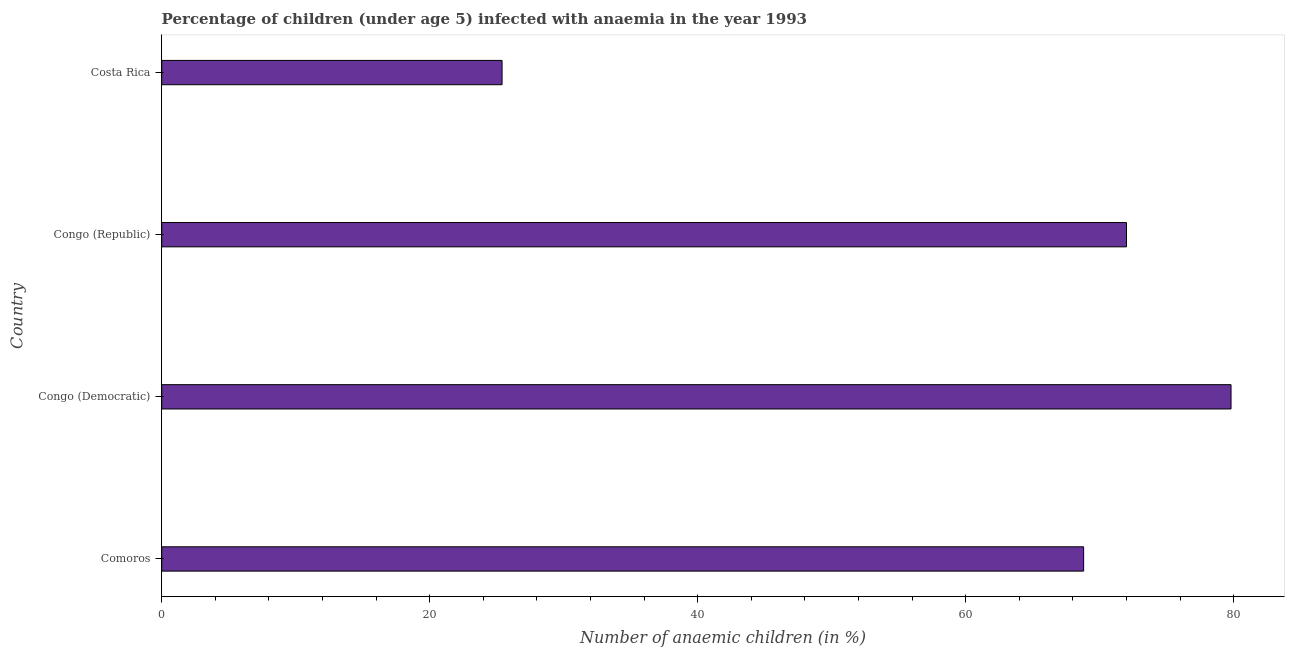Does the graph contain any zero values?
Provide a short and direct response. No. What is the title of the graph?
Give a very brief answer. Percentage of children (under age 5) infected with anaemia in the year 1993. What is the label or title of the X-axis?
Your response must be concise. Number of anaemic children (in %). What is the number of anaemic children in Costa Rica?
Your answer should be very brief. 25.4. Across all countries, what is the maximum number of anaemic children?
Your answer should be very brief. 79.8. Across all countries, what is the minimum number of anaemic children?
Your answer should be very brief. 25.4. In which country was the number of anaemic children maximum?
Offer a terse response. Congo (Democratic). In which country was the number of anaemic children minimum?
Your answer should be compact. Costa Rica. What is the sum of the number of anaemic children?
Keep it short and to the point. 246. What is the difference between the number of anaemic children in Congo (Democratic) and Costa Rica?
Make the answer very short. 54.4. What is the average number of anaemic children per country?
Your response must be concise. 61.5. What is the median number of anaemic children?
Your answer should be very brief. 70.4. In how many countries, is the number of anaemic children greater than 16 %?
Make the answer very short. 4. What is the ratio of the number of anaemic children in Comoros to that in Costa Rica?
Your answer should be very brief. 2.71. Is the number of anaemic children in Comoros less than that in Congo (Republic)?
Provide a succinct answer. Yes. Is the difference between the number of anaemic children in Congo (Democratic) and Costa Rica greater than the difference between any two countries?
Give a very brief answer. Yes. What is the difference between the highest and the second highest number of anaemic children?
Keep it short and to the point. 7.8. Is the sum of the number of anaemic children in Congo (Republic) and Costa Rica greater than the maximum number of anaemic children across all countries?
Your answer should be compact. Yes. What is the difference between the highest and the lowest number of anaemic children?
Your answer should be compact. 54.4. How many bars are there?
Give a very brief answer. 4. Are all the bars in the graph horizontal?
Offer a very short reply. Yes. How many countries are there in the graph?
Give a very brief answer. 4. What is the difference between two consecutive major ticks on the X-axis?
Ensure brevity in your answer.  20. Are the values on the major ticks of X-axis written in scientific E-notation?
Provide a short and direct response. No. What is the Number of anaemic children (in %) in Comoros?
Ensure brevity in your answer.  68.8. What is the Number of anaemic children (in %) in Congo (Democratic)?
Your answer should be very brief. 79.8. What is the Number of anaemic children (in %) of Costa Rica?
Provide a short and direct response. 25.4. What is the difference between the Number of anaemic children (in %) in Comoros and Congo (Democratic)?
Your answer should be very brief. -11. What is the difference between the Number of anaemic children (in %) in Comoros and Congo (Republic)?
Give a very brief answer. -3.2. What is the difference between the Number of anaemic children (in %) in Comoros and Costa Rica?
Your response must be concise. 43.4. What is the difference between the Number of anaemic children (in %) in Congo (Democratic) and Congo (Republic)?
Provide a short and direct response. 7.8. What is the difference between the Number of anaemic children (in %) in Congo (Democratic) and Costa Rica?
Ensure brevity in your answer.  54.4. What is the difference between the Number of anaemic children (in %) in Congo (Republic) and Costa Rica?
Provide a succinct answer. 46.6. What is the ratio of the Number of anaemic children (in %) in Comoros to that in Congo (Democratic)?
Make the answer very short. 0.86. What is the ratio of the Number of anaemic children (in %) in Comoros to that in Congo (Republic)?
Make the answer very short. 0.96. What is the ratio of the Number of anaemic children (in %) in Comoros to that in Costa Rica?
Your answer should be very brief. 2.71. What is the ratio of the Number of anaemic children (in %) in Congo (Democratic) to that in Congo (Republic)?
Offer a terse response. 1.11. What is the ratio of the Number of anaemic children (in %) in Congo (Democratic) to that in Costa Rica?
Make the answer very short. 3.14. What is the ratio of the Number of anaemic children (in %) in Congo (Republic) to that in Costa Rica?
Offer a very short reply. 2.83. 